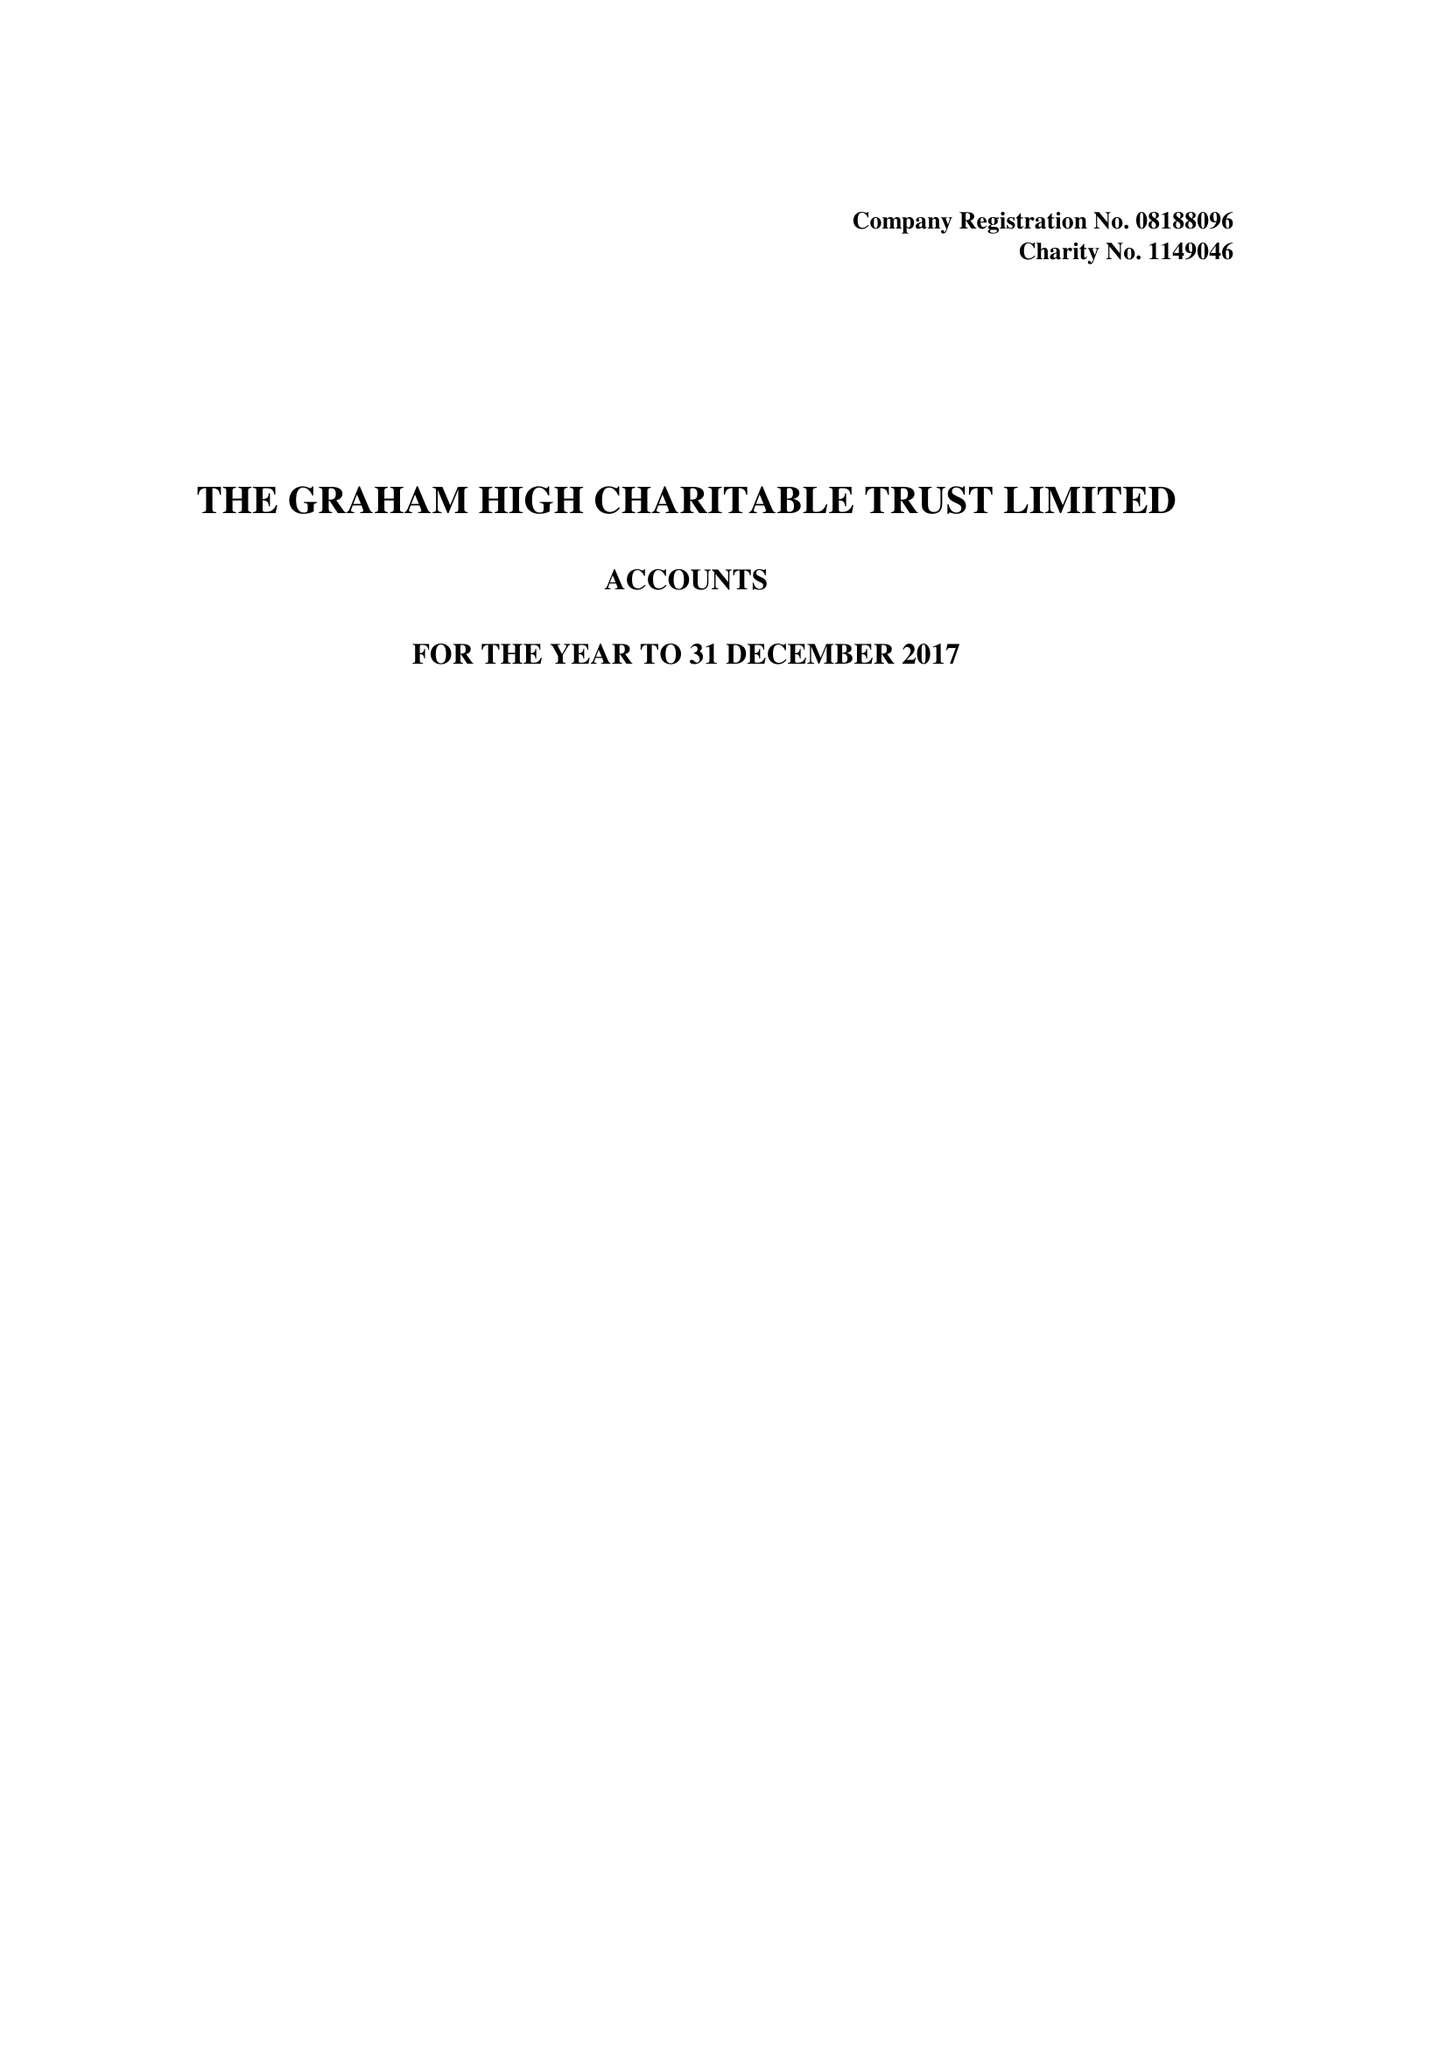What is the value for the charity_name?
Answer the question using a single word or phrase. The Graham High Charitable Trust Ltd. 